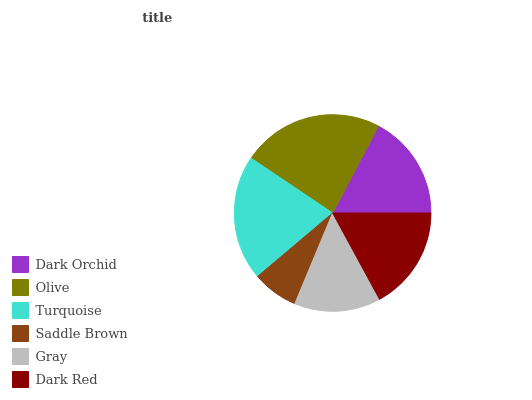Is Saddle Brown the minimum?
Answer yes or no. Yes. Is Olive the maximum?
Answer yes or no. Yes. Is Turquoise the minimum?
Answer yes or no. No. Is Turquoise the maximum?
Answer yes or no. No. Is Olive greater than Turquoise?
Answer yes or no. Yes. Is Turquoise less than Olive?
Answer yes or no. Yes. Is Turquoise greater than Olive?
Answer yes or no. No. Is Olive less than Turquoise?
Answer yes or no. No. Is Dark Orchid the high median?
Answer yes or no. Yes. Is Dark Red the low median?
Answer yes or no. Yes. Is Turquoise the high median?
Answer yes or no. No. Is Saddle Brown the low median?
Answer yes or no. No. 